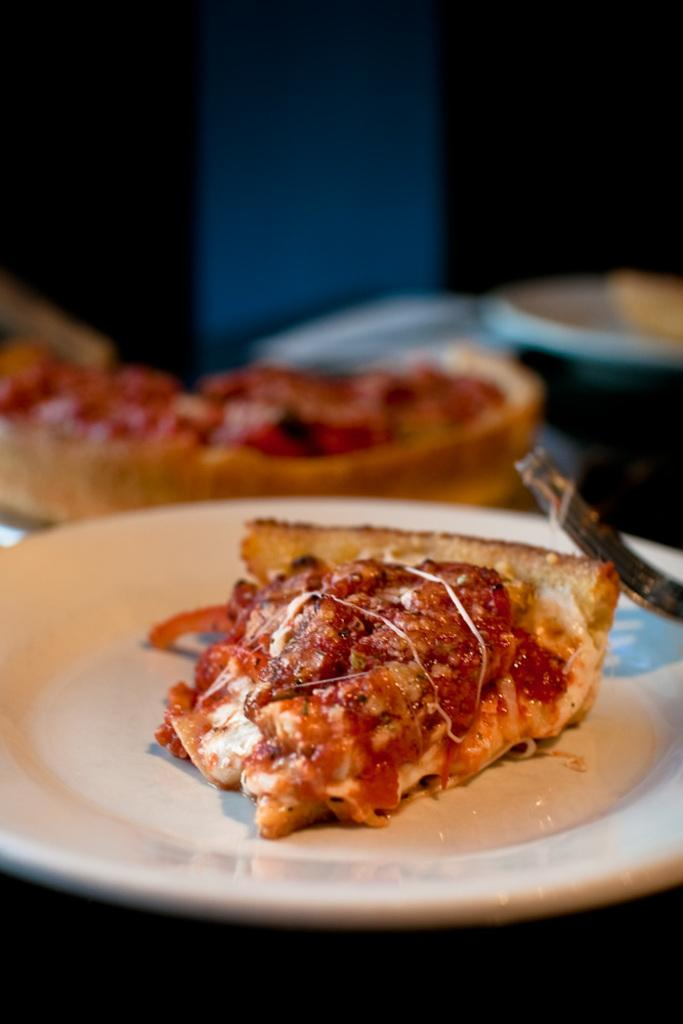What is present on the plate in the image? There is food on the plate in the image. What utensil is placed with the food on the plate? There is a fork on the plate. What type of humor can be seen in the image? There is no humor present in the image; it features a plate with food and a fork. 